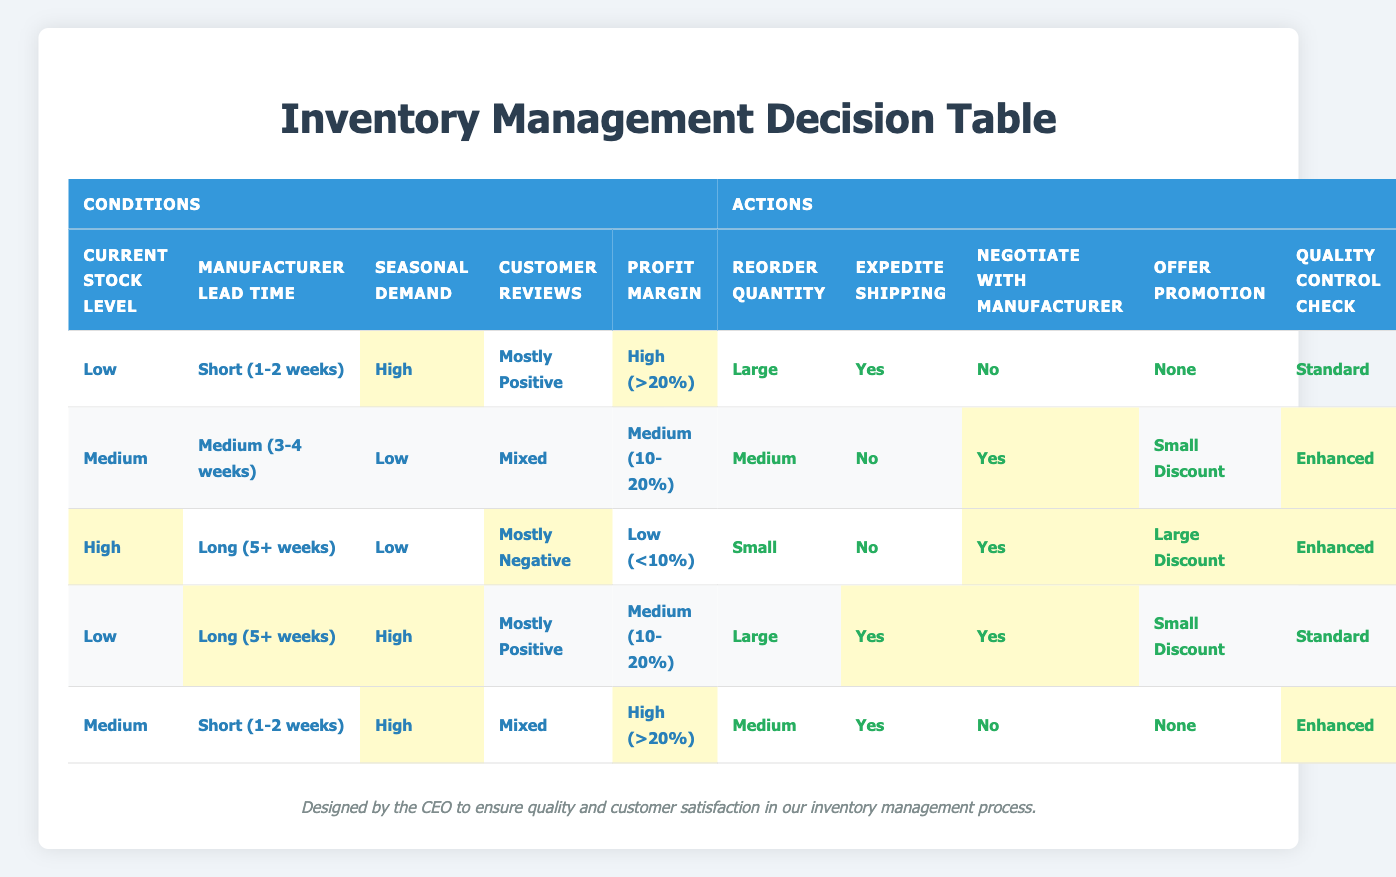What is the reorder quantity when the current stock level is low, and seasonal demand is high? In the row where the current stock level is low and seasonal demand is high, the reorder quantity is listed as large.
Answer: Large What is the action for expedite shipping when the customer reviews are mixed and the profit margin is medium? In the row where customer reviews are mixed and profit margin is medium, the expedite shipping action is listed as no.
Answer: No In how many cases is the quality control check enhanced? To find this, we look for “Enhanced” in the Quality Control Check column and count the occurrences. By examining the table, there are three instances where the check is enhanced.
Answer: 3 Is there a scenario where the profit margin is low but the reorder quantity is large? By examining the rows, the profit margin cannot be low in any row where the reorder quantity is large. Therefore, the scenario does not exist.
Answer: No What is the relationship between manufacturer lead time and the decision to negotiate with the manufacturer? By examining the rows, the decision to negotiate with the manufacturer is "Yes" in the cases of long lead time with low stock and also when stock is low with high demand. In all other cases of medium or short lead time, it is "No."
Answer: It varies: Yes for long lead time low stock, No for others When the current stock level is high, what promotion is offered when customer reviews are mostly negative? In the row for high current stock level and mostly negative reviews, the promotion offered is a large discount.
Answer: Large Discount What is the average reorder quantity when the seasonal demand is high? The reorder quantities associated with high seasonal demand are large, medium, and medium (from the relevant rows). Converting them into numerical values (assuming large=3, medium=2), the total is 3 + 2 + 2 = 7. Dividing by 3 (the number of instances) gives an average of 2.33, which corresponds to medium in this case.
Answer: Medium How does the expedite shipping decision change based on the current stock level? The expedite shipping decision is yes when the current stock level is low, irrespective of lead time and customer reviews. When stock is medium or high, the decision is no or requires careful consideration based on other factors.
Answer: It varies; Yes when low, No typically when medium/high Under what conditions does a large discount get offered? A large discount is offered when the current stock level is high with mostly negative reviews and low profit margin. It is also part of a strategy when customer reviews are mostly positive under low stock and long lead time.
Answer: High stock, mostly negative reviews; Low stock, positive reviews 